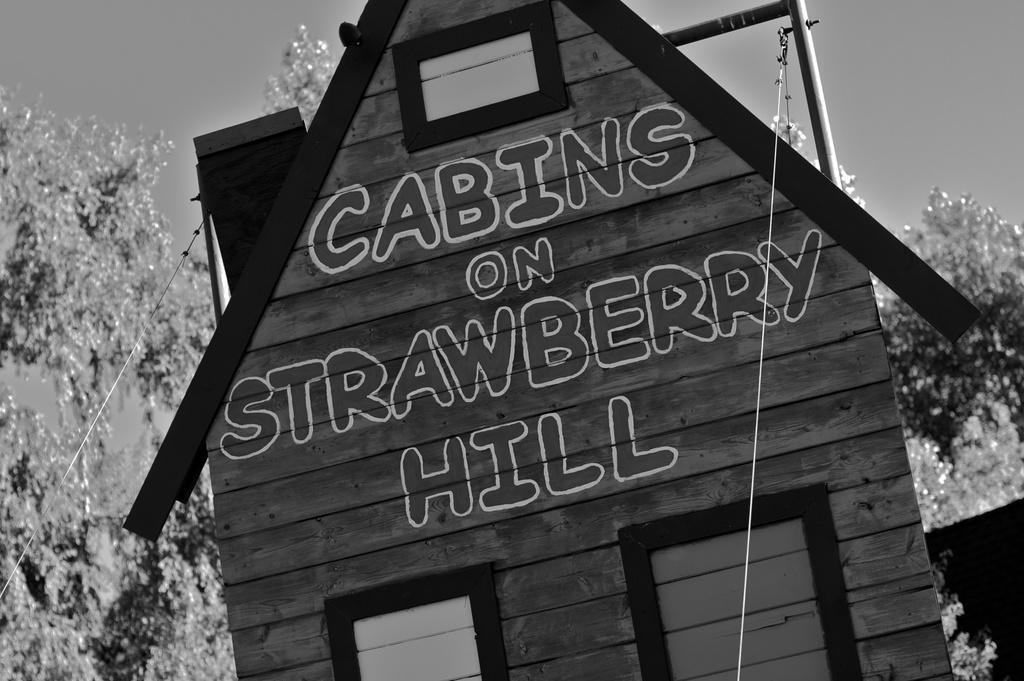In one or two sentences, can you explain what this image depicts? This is a black and white picture. In the center of the picture there is a building. In the background there are trees. In the foreground there are cables. 